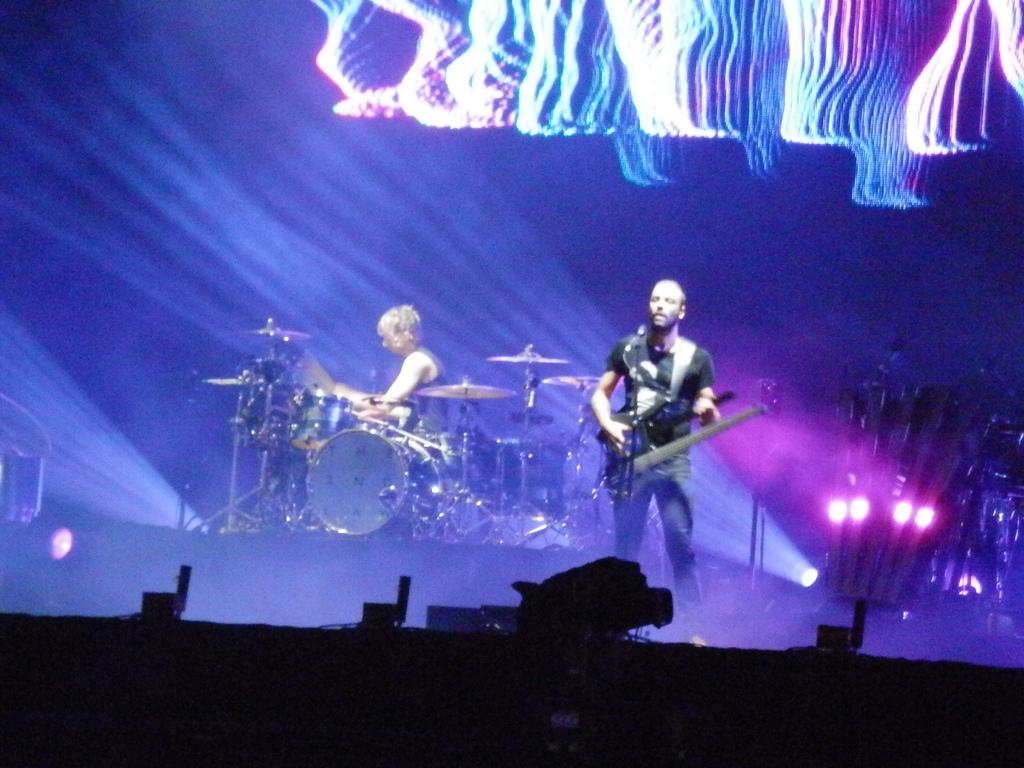How many people are in the image? There are two persons in the image. What are the persons doing in the image? Both persons are playing musical instruments. What instrument is the person on the right side playing? The person on the right side is playing a guitar. What object is in front of the person on the right side? The person on the right side is in front of a microphone. Where does the scene take place? The scene takes place on a stage. What type of zipper can be seen on the guitar in the image? There is no zipper present on the guitar in the image. Are there any police officers visible in the image? There are no police officers present in the image. 